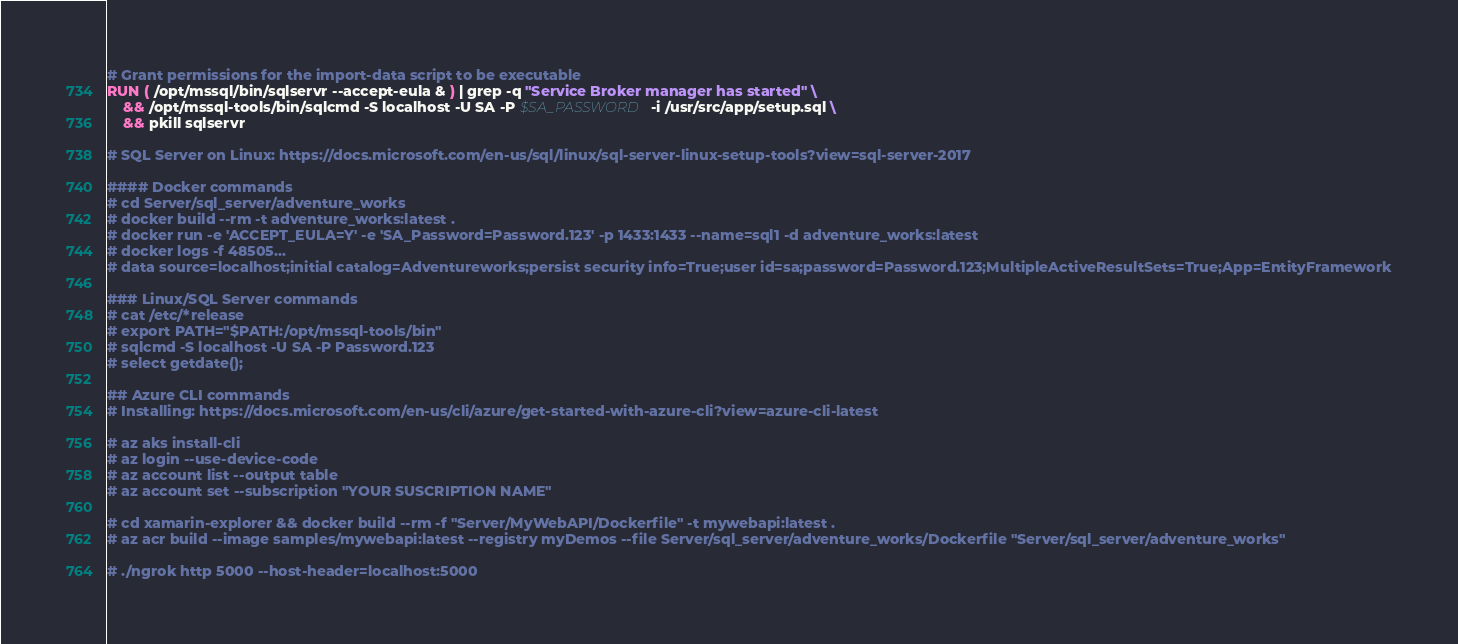Convert code to text. <code><loc_0><loc_0><loc_500><loc_500><_Dockerfile_>
# Grant permissions for the import-data script to be executable
RUN ( /opt/mssql/bin/sqlservr --accept-eula & ) | grep -q "Service Broker manager has started" \
    && /opt/mssql-tools/bin/sqlcmd -S localhost -U SA -P $SA_PASSWORD -i /usr/src/app/setup.sql \
    && pkill sqlservr 

# SQL Server on Linux: https://docs.microsoft.com/en-us/sql/linux/sql-server-linux-setup-tools?view=sql-server-2017

#### Docker commands
# cd Server/sql_server/adventure_works
# docker build --rm -t adventure_works:latest . 
# docker run -e 'ACCEPT_EULA=Y' -e 'SA_Password=Password.123' -p 1433:1433 --name=sql1 -d adventure_works:latest
# docker logs -f 48505...
# data source=localhost;initial catalog=Adventureworks;persist security info=True;user id=sa;password=Password.123;MultipleActiveResultSets=True;App=EntityFramework

### Linux/SQL Server commands 
# cat /etc/*release
# export PATH="$PATH:/opt/mssql-tools/bin"
# sqlcmd -S localhost -U SA -P Password.123
# select getdate();

## Azure CLI commands
# Installing: https://docs.microsoft.com/en-us/cli/azure/get-started-with-azure-cli?view=azure-cli-latest

# az aks install-cli
# az login --use-device-code
# az account list --output table
# az account set --subscription "YOUR SUSCRIPTION NAME"

# cd xamarin-explorer && docker build --rm -f "Server/MyWebAPI/Dockerfile" -t mywebapi:latest .
# az acr build --image samples/mywebapi:latest --registry myDemos --file Server/sql_server/adventure_works/Dockerfile "Server/sql_server/adventure_works"

# ./ngrok http 5000 --host-header=localhost:5000</code> 